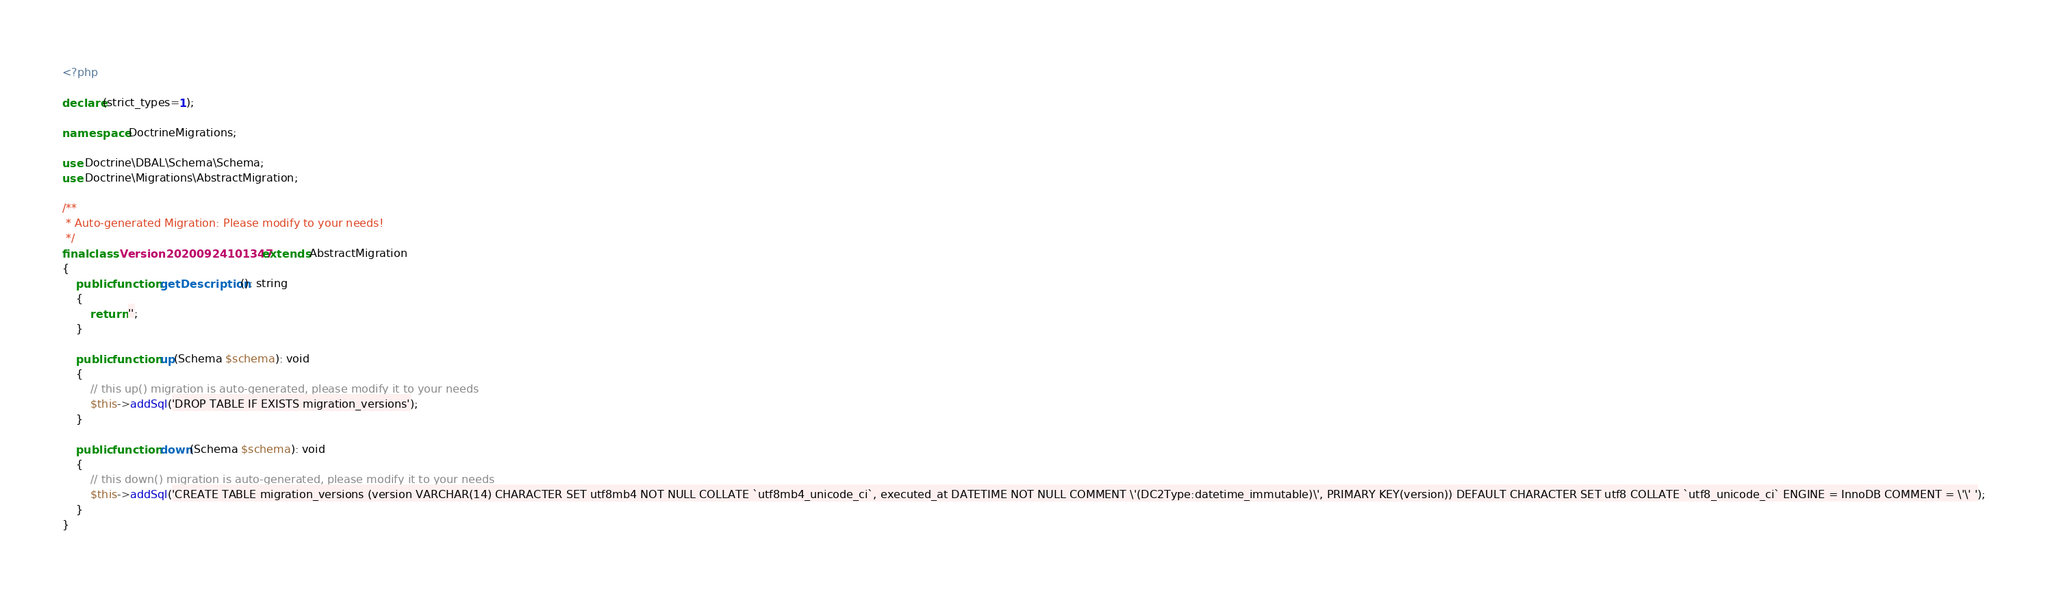Convert code to text. <code><loc_0><loc_0><loc_500><loc_500><_PHP_><?php

declare(strict_types=1);

namespace DoctrineMigrations;

use Doctrine\DBAL\Schema\Schema;
use Doctrine\Migrations\AbstractMigration;

/**
 * Auto-generated Migration: Please modify to your needs!
 */
final class Version20200924101347 extends AbstractMigration
{
    public function getDescription(): string
    {
        return '';
    }

    public function up(Schema $schema): void
    {
        // this up() migration is auto-generated, please modify it to your needs
        $this->addSql('DROP TABLE IF EXISTS migration_versions');
    }

    public function down(Schema $schema): void
    {
        // this down() migration is auto-generated, please modify it to your needs
        $this->addSql('CREATE TABLE migration_versions (version VARCHAR(14) CHARACTER SET utf8mb4 NOT NULL COLLATE `utf8mb4_unicode_ci`, executed_at DATETIME NOT NULL COMMENT \'(DC2Type:datetime_immutable)\', PRIMARY KEY(version)) DEFAULT CHARACTER SET utf8 COLLATE `utf8_unicode_ci` ENGINE = InnoDB COMMENT = \'\' ');
    }
}
</code> 